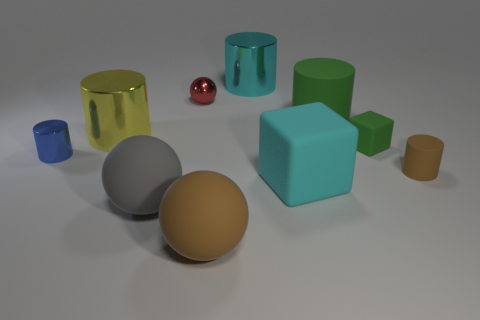How many rubber things are either blue balls or tiny green things? In the image, there is one small blue rubber ball, which matches one part of the criteria. However, there don't appear to be any rubber objects that are tiny and green. Therefore, there is a total of 1 item that fits the description provided. 